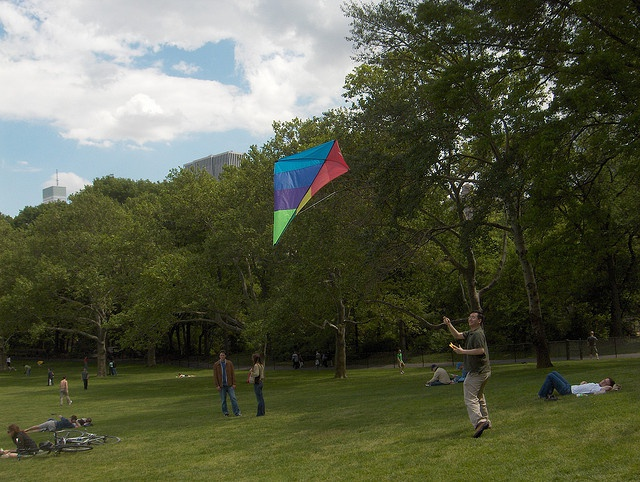Describe the objects in this image and their specific colors. I can see kite in lightgray, blue, brown, and purple tones, people in lightgray, black, and gray tones, people in lightgray, black, darkgreen, and gray tones, bicycle in lightgray, darkgreen, black, gray, and darkgray tones, and people in lightgray, black, darkgray, gray, and navy tones in this image. 